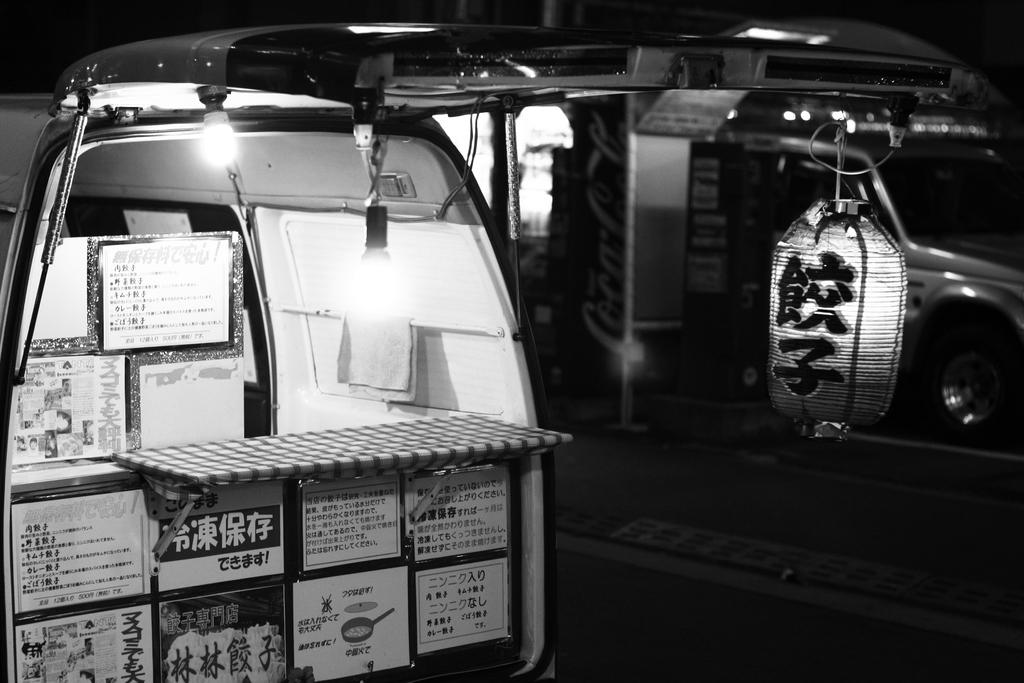What is the setting of the image? The image shows the inside of a vehicle. What can be seen inside the vehicle? There are boxes placed inside the vehicle. Are there any visible light sources in the image? Yes, there are lights visible in the image. What type of holiday decoration can be seen hanging from the ceiling in the image? There is no holiday decoration present in the image; it shows the inside of a vehicle with boxes and lights. How many stars are visible in the image? There are no stars visible in the image; it shows the inside of a vehicle with boxes and lights. 